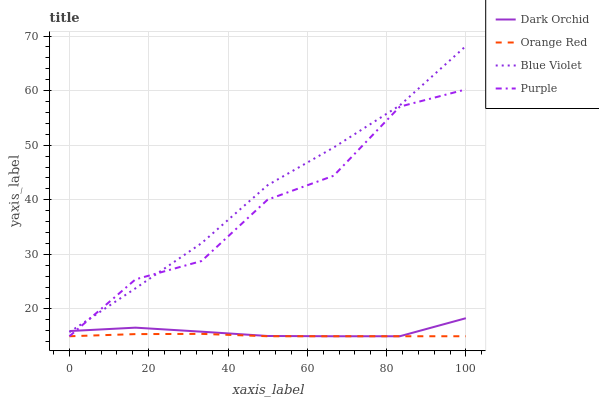Does Orange Red have the minimum area under the curve?
Answer yes or no. Yes. Does Blue Violet have the maximum area under the curve?
Answer yes or no. Yes. Does Purple have the minimum area under the curve?
Answer yes or no. No. Does Purple have the maximum area under the curve?
Answer yes or no. No. Is Orange Red the smoothest?
Answer yes or no. Yes. Is Purple the roughest?
Answer yes or no. Yes. Is Purple the smoothest?
Answer yes or no. No. Is Orange Red the roughest?
Answer yes or no. No. Does Blue Violet have the highest value?
Answer yes or no. Yes. Does Purple have the highest value?
Answer yes or no. No. Is Orange Red less than Blue Violet?
Answer yes or no. Yes. Is Blue Violet greater than Orange Red?
Answer yes or no. Yes. Does Blue Violet intersect Dark Orchid?
Answer yes or no. Yes. Is Blue Violet less than Dark Orchid?
Answer yes or no. No. Is Blue Violet greater than Dark Orchid?
Answer yes or no. No. Does Orange Red intersect Blue Violet?
Answer yes or no. No. 